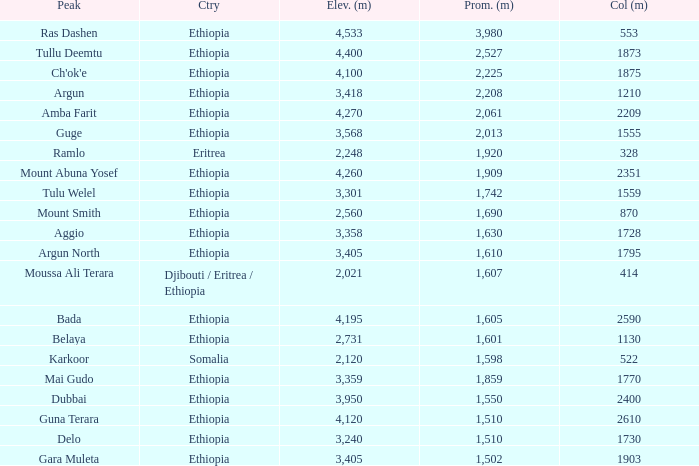What is the total prominence number in m of ethiopia, which has a col in m of 1728 and an elevation less than 3,358? 0.0. 